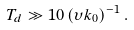<formula> <loc_0><loc_0><loc_500><loc_500>T _ { d } \gg 1 0 \, ( \upsilon k _ { 0 } ) ^ { - 1 } \, .</formula> 